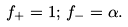<formula> <loc_0><loc_0><loc_500><loc_500>f _ { + } = 1 ; \, f _ { - } = \alpha .</formula> 